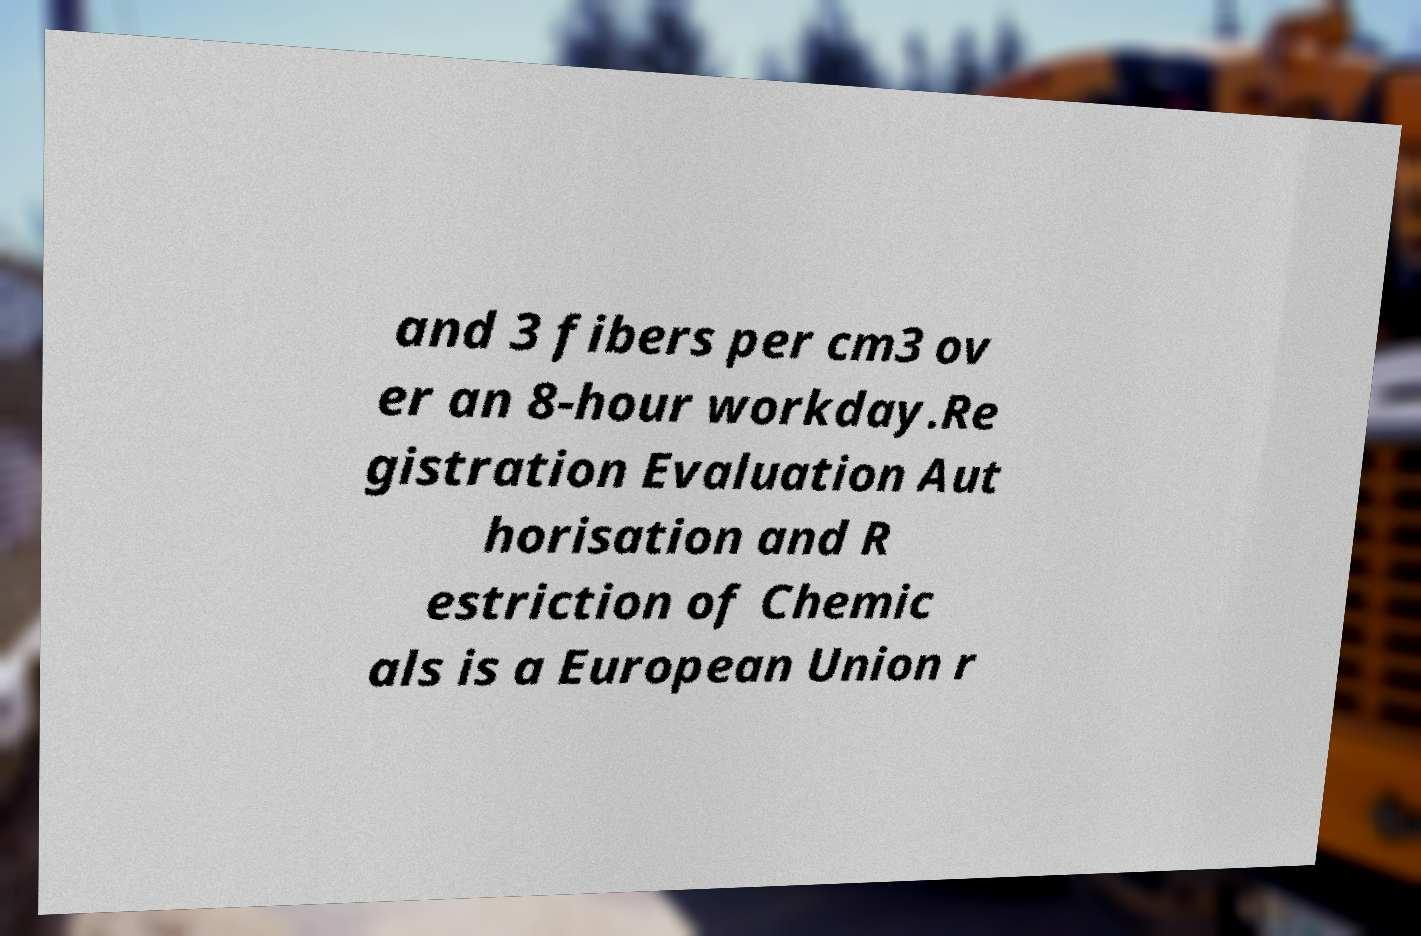Can you accurately transcribe the text from the provided image for me? and 3 fibers per cm3 ov er an 8-hour workday.Re gistration Evaluation Aut horisation and R estriction of Chemic als is a European Union r 